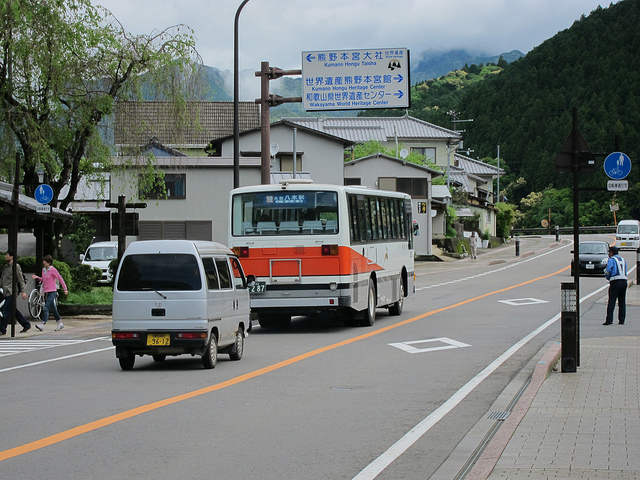<image>What does it say on the white sign? I don't know what it says on the white sign. It could be in Chinese or it could be an advertisement. What does it say on the white sign? It is ambiguous what it says on the white sign. It can be seen as "chinese language", "eat at sal's", "foreign language", "in chinese", "road stop soon", or "advertising". 